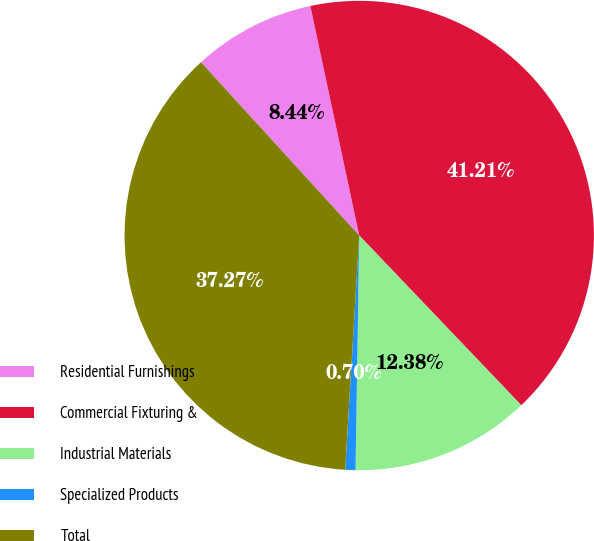Convert chart. <chart><loc_0><loc_0><loc_500><loc_500><pie_chart><fcel>Residential Furnishings<fcel>Commercial Fixturing &<fcel>Industrial Materials<fcel>Specialized Products<fcel>Total<nl><fcel>8.44%<fcel>41.21%<fcel>12.38%<fcel>0.7%<fcel>37.27%<nl></chart> 